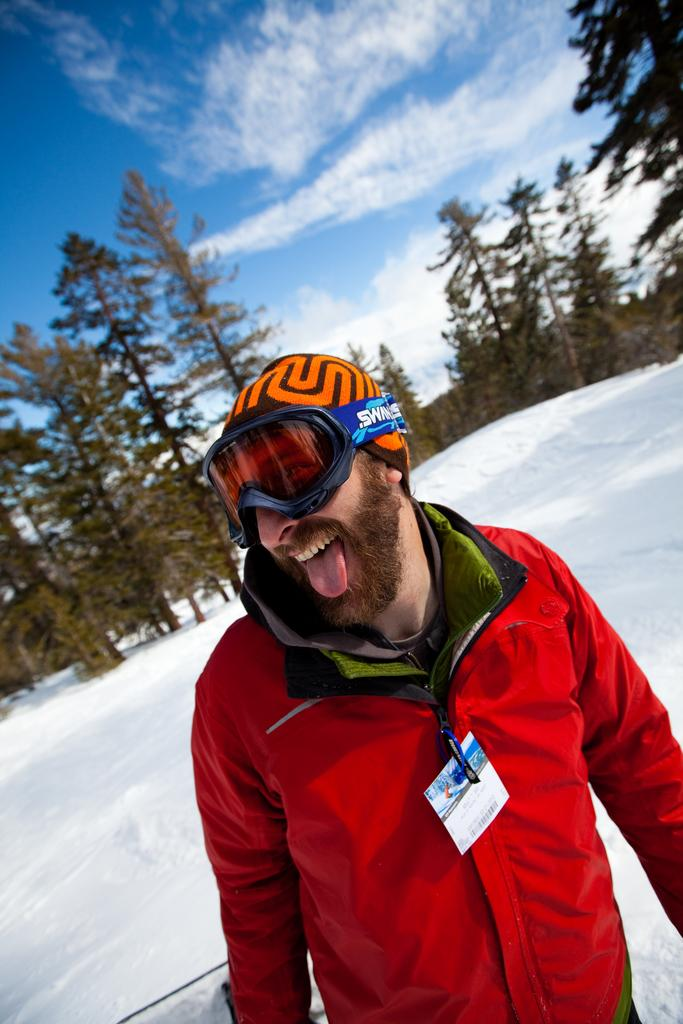What is the main subject of the image? There is a person standing in the image. What can be seen in the background of the image? There are trees and snow visible in the background of the image. How would you describe the weather based on the image? The sky is cloudy in the background of the image, which suggests a potentially overcast or snowy day. What is the price of the wine being served in the image? There is no wine or any indication of a price in the image. 